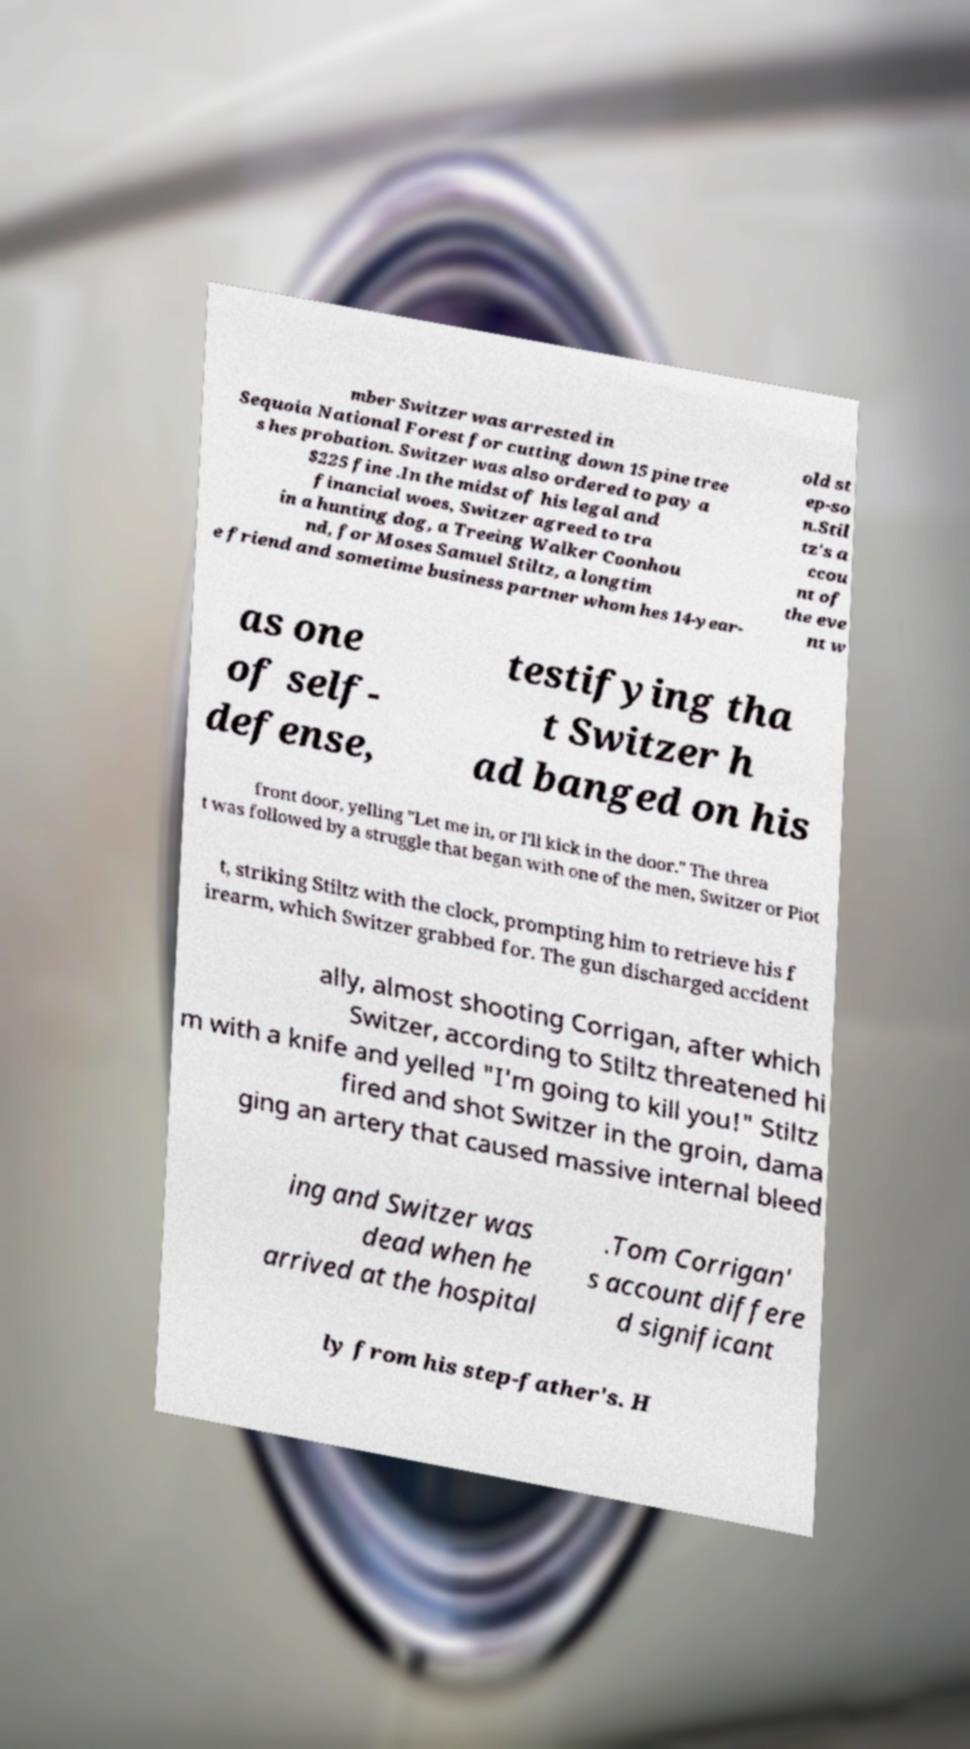Can you read and provide the text displayed in the image?This photo seems to have some interesting text. Can you extract and type it out for me? mber Switzer was arrested in Sequoia National Forest for cutting down 15 pine tree s hes probation. Switzer was also ordered to pay a $225 fine .In the midst of his legal and financial woes, Switzer agreed to tra in a hunting dog, a Treeing Walker Coonhou nd, for Moses Samuel Stiltz, a longtim e friend and sometime business partner whom hes 14-year- old st ep-so n.Stil tz's a ccou nt of the eve nt w as one of self- defense, testifying tha t Switzer h ad banged on his front door, yelling "Let me in, or I'll kick in the door." The threa t was followed by a struggle that began with one of the men, Switzer or Piot t, striking Stiltz with the clock, prompting him to retrieve his f irearm, which Switzer grabbed for. The gun discharged accident ally, almost shooting Corrigan, after which Switzer, according to Stiltz threatened hi m with a knife and yelled "I'm going to kill you!" Stiltz fired and shot Switzer in the groin, dama ging an artery that caused massive internal bleed ing and Switzer was dead when he arrived at the hospital .Tom Corrigan' s account differe d significant ly from his step-father's. H 